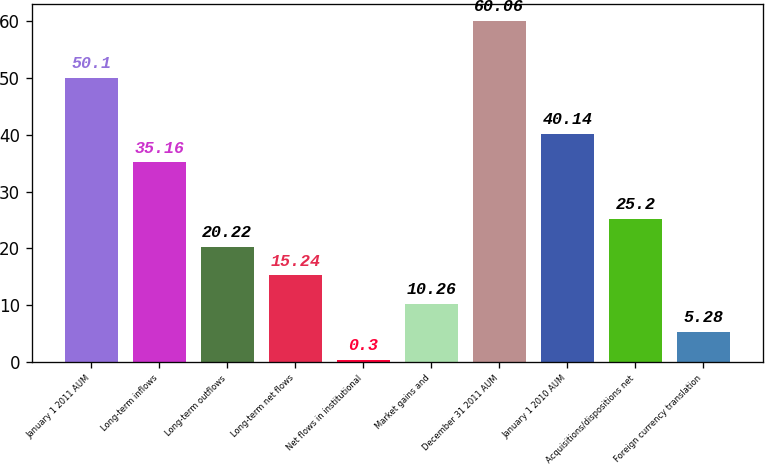Convert chart. <chart><loc_0><loc_0><loc_500><loc_500><bar_chart><fcel>January 1 2011 AUM<fcel>Long-term inflows<fcel>Long-term outflows<fcel>Long-term net flows<fcel>Net flows in institutional<fcel>Market gains and<fcel>December 31 2011 AUM<fcel>January 1 2010 AUM<fcel>Acquisitions/dispositions net<fcel>Foreign currency translation<nl><fcel>50.1<fcel>35.16<fcel>20.22<fcel>15.24<fcel>0.3<fcel>10.26<fcel>60.06<fcel>40.14<fcel>25.2<fcel>5.28<nl></chart> 